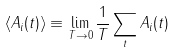Convert formula to latex. <formula><loc_0><loc_0><loc_500><loc_500>\langle A _ { i } ( t ) \rangle \equiv \lim _ { T \rightarrow 0 } \frac { 1 } { T } \sum _ { t } A _ { i } ( t )</formula> 